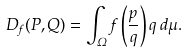Convert formula to latex. <formula><loc_0><loc_0><loc_500><loc_500>D _ { f } ( P , Q ) = \int _ { \Omega } f \left ( \frac { p } { q } \right ) q \, d \mu .</formula> 